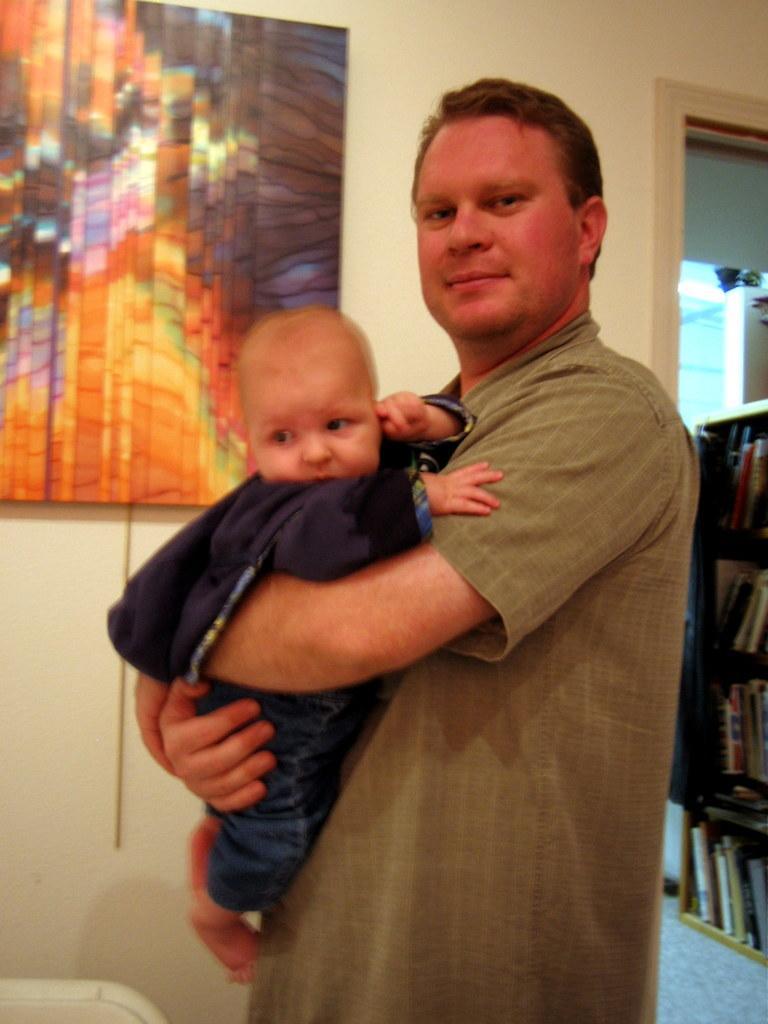In one or two sentences, can you explain what this image depicts? In this image I see a man who is holding this baby and in the background I see the wall and I see a frame over here which is colorful and I see number of books in these racks and I see the floor. 